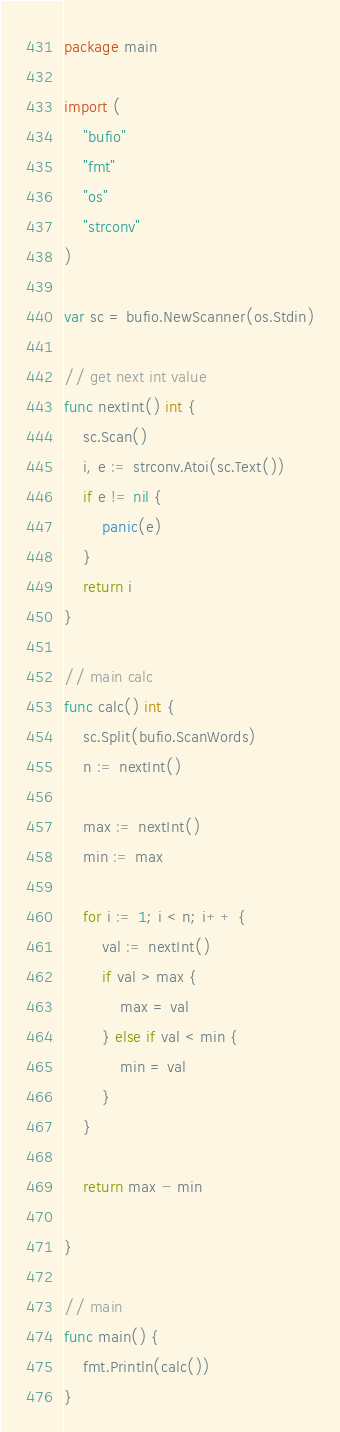<code> <loc_0><loc_0><loc_500><loc_500><_Go_>package main

import (
	"bufio"
	"fmt"
	"os"
	"strconv"
)

var sc = bufio.NewScanner(os.Stdin)

// get next int value
func nextInt() int {
	sc.Scan()
	i, e := strconv.Atoi(sc.Text())
	if e != nil {
		panic(e)
	}
	return i
}

// main calc
func calc() int {
	sc.Split(bufio.ScanWords)
	n := nextInt()

	max := nextInt()
	min := max

	for i := 1; i < n; i++ {
		val := nextInt()
		if val > max {
			max = val
		} else if val < min {
			min = val
		}
	}

	return max - min

}

// main
func main() {
	fmt.Println(calc())
}
</code> 